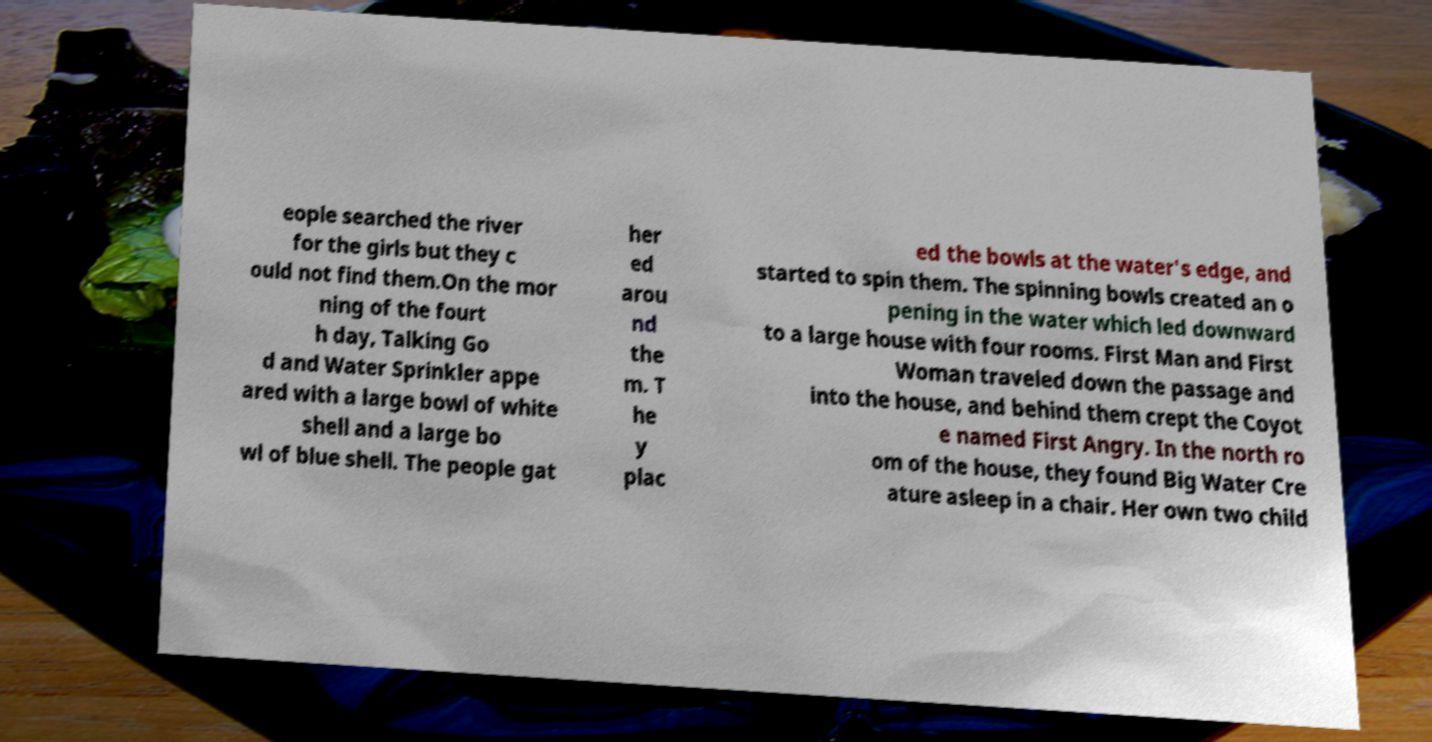What messages or text are displayed in this image? I need them in a readable, typed format. eople searched the river for the girls but they c ould not find them.On the mor ning of the fourt h day, Talking Go d and Water Sprinkler appe ared with a large bowl of white shell and a large bo wl of blue shell. The people gat her ed arou nd the m. T he y plac ed the bowls at the water's edge, and started to spin them. The spinning bowls created an o pening in the water which led downward to a large house with four rooms. First Man and First Woman traveled down the passage and into the house, and behind them crept the Coyot e named First Angry. In the north ro om of the house, they found Big Water Cre ature asleep in a chair. Her own two child 